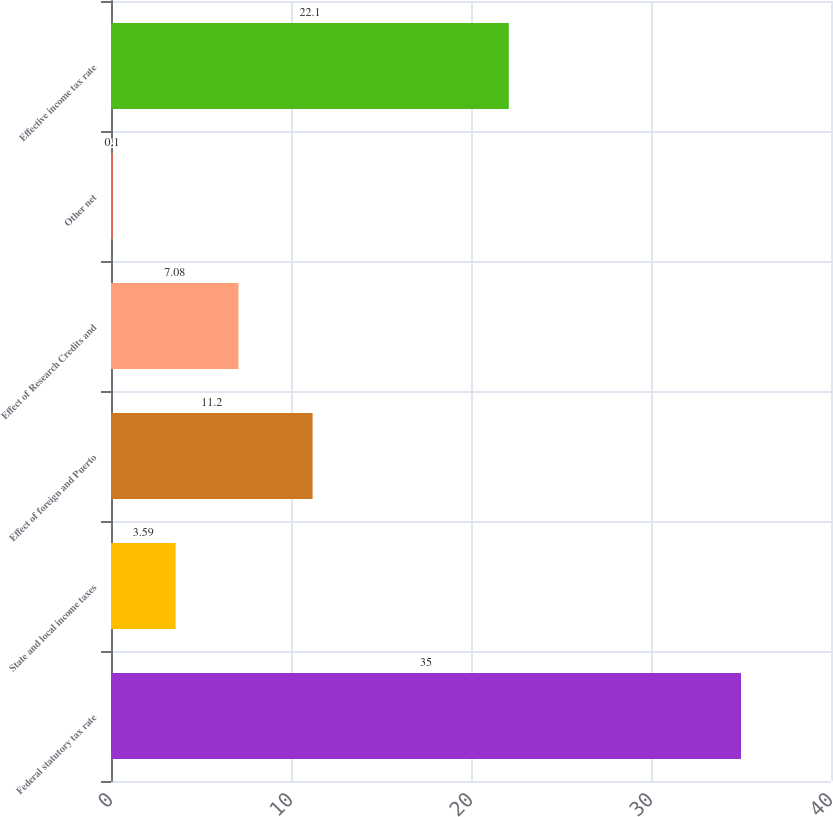Convert chart to OTSL. <chart><loc_0><loc_0><loc_500><loc_500><bar_chart><fcel>Federal statutory tax rate<fcel>State and local income taxes<fcel>Effect of foreign and Puerto<fcel>Effect of Research Credits and<fcel>Other net<fcel>Effective income tax rate<nl><fcel>35<fcel>3.59<fcel>11.2<fcel>7.08<fcel>0.1<fcel>22.1<nl></chart> 